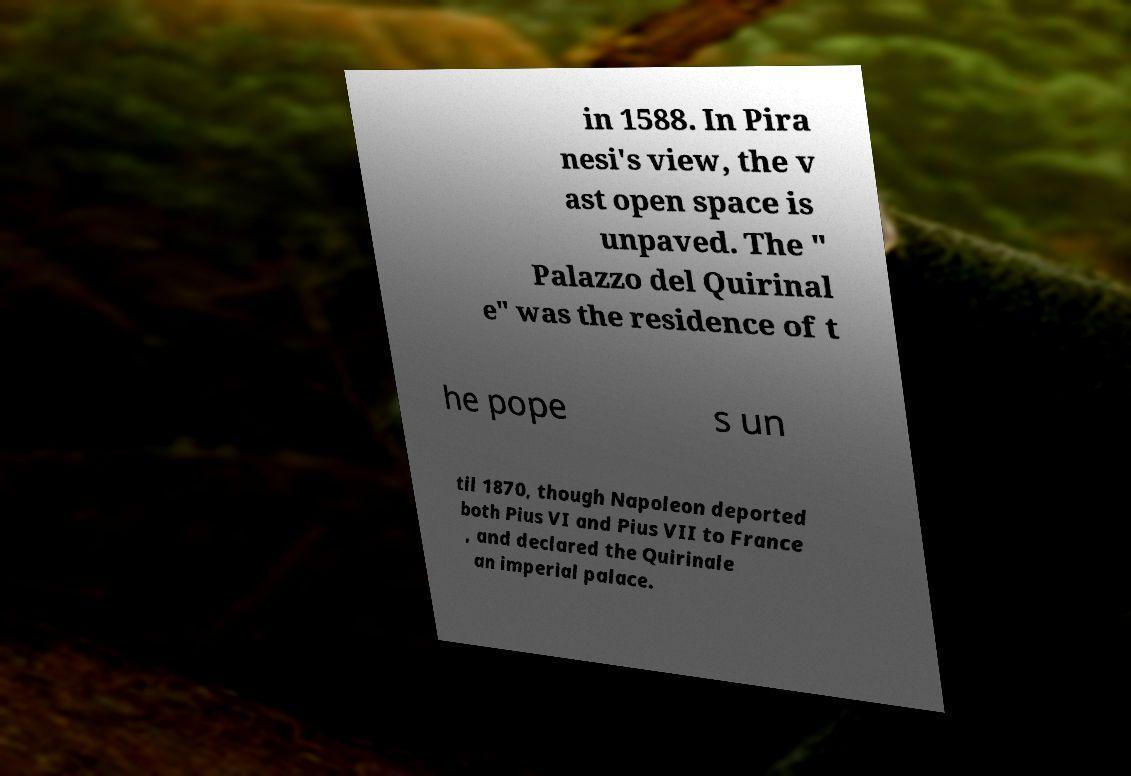I need the written content from this picture converted into text. Can you do that? in 1588. In Pira nesi's view, the v ast open space is unpaved. The " Palazzo del Quirinal e" was the residence of t he pope s un til 1870, though Napoleon deported both Pius VI and Pius VII to France , and declared the Quirinale an imperial palace. 